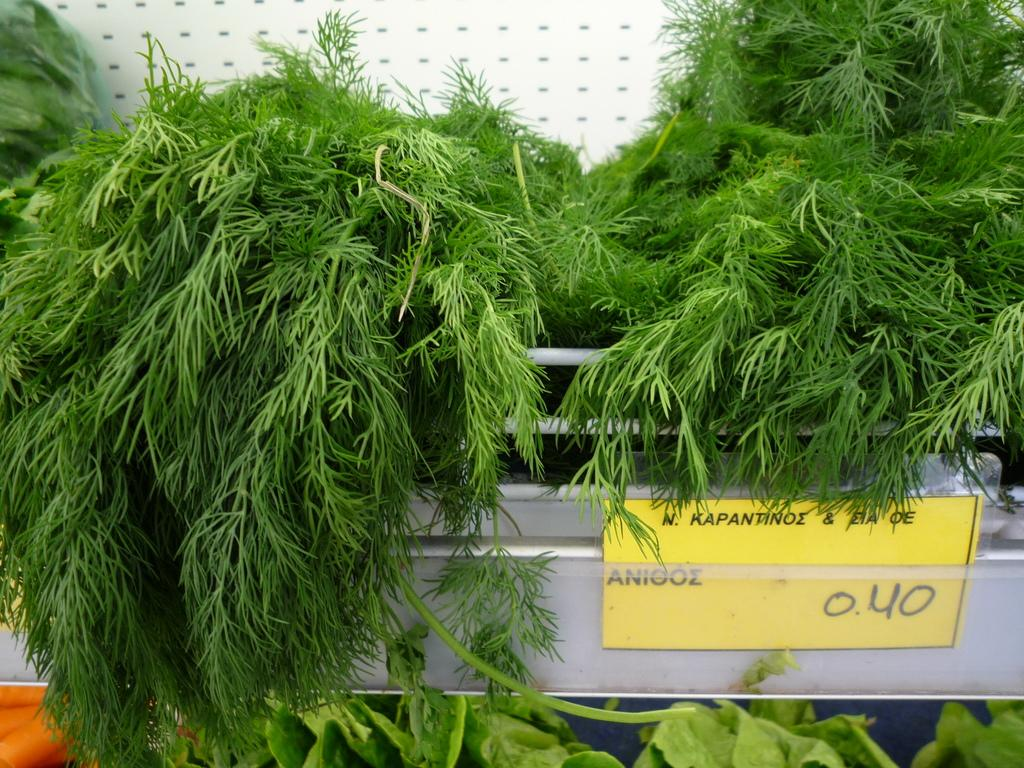What type of living organisms can be seen in the image? Plants can be seen in the image. What color are the plants in the image? The plants are green. What other object is present in the image besides the plants? There is a board in the image. What color is the board in the image? The board is yellow. What color is the background of the image? The background of the image is white. What type of song can be heard playing in the background of the image? There is no sound or music present in the image, so it is not possible to determine what song might be heard. 